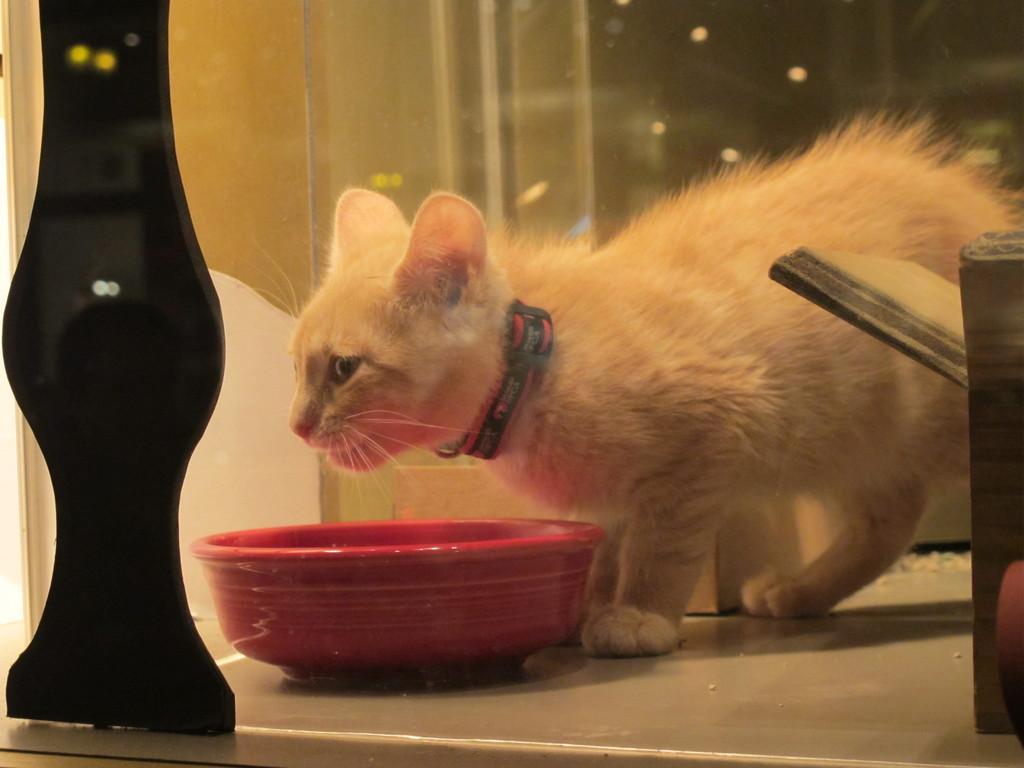In one or two sentences, can you explain what this image depicts? In this image there is a white color cat on the right side of this image and there is a bowl on the bottom of this image. There is a wall in the background and there is a black color object on the left side of this image and there is one another object is at on the right side of this image. 